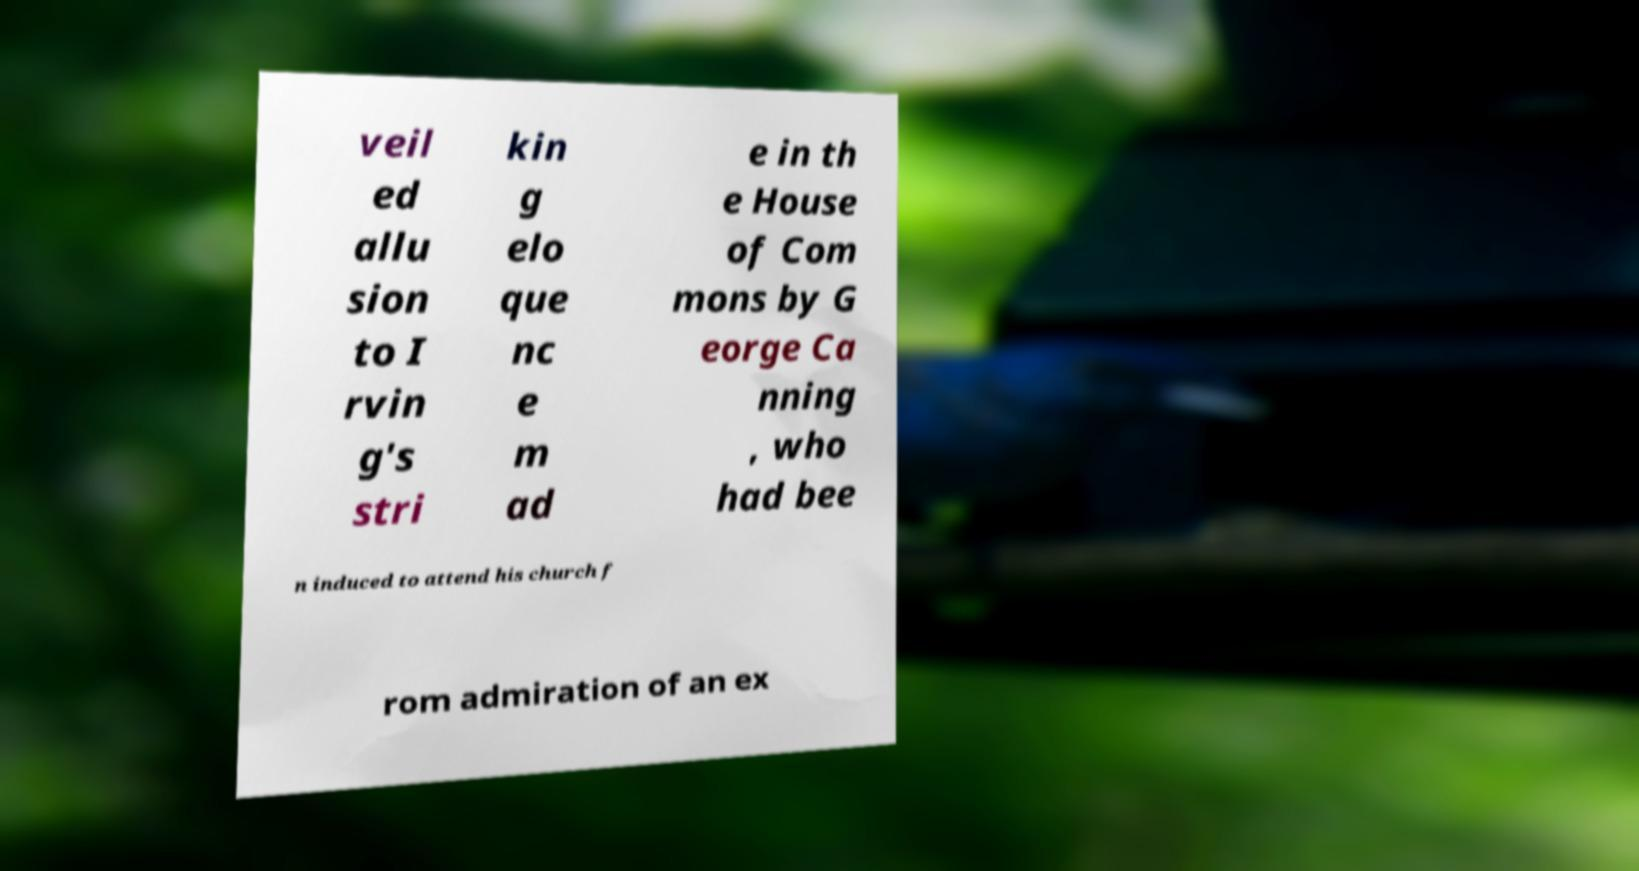I need the written content from this picture converted into text. Can you do that? veil ed allu sion to I rvin g's stri kin g elo que nc e m ad e in th e House of Com mons by G eorge Ca nning , who had bee n induced to attend his church f rom admiration of an ex 